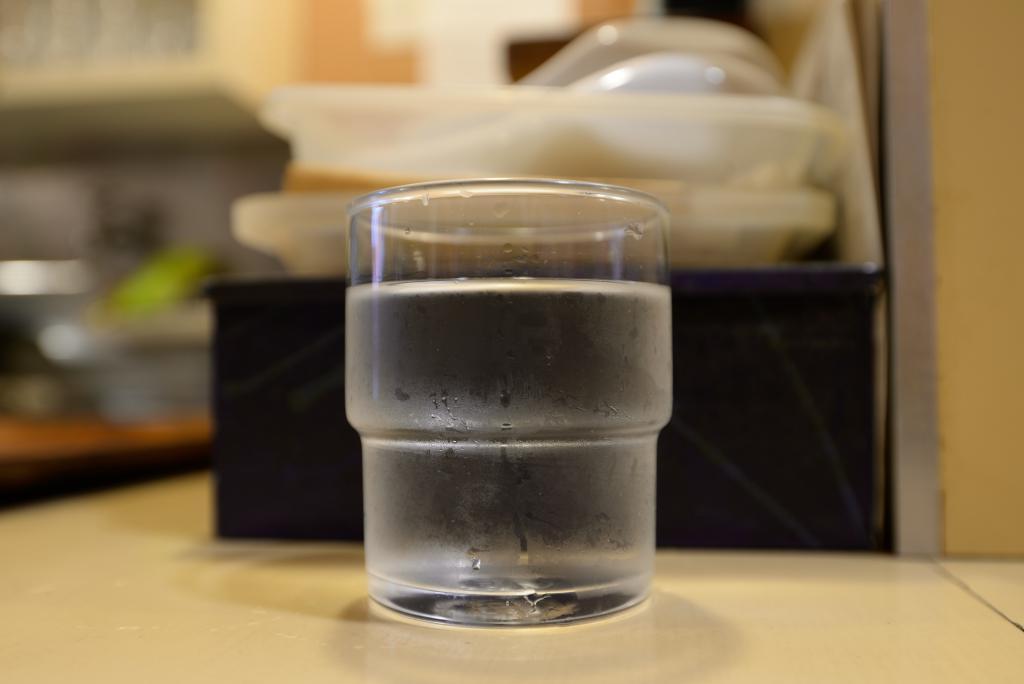How would you summarize this image in a sentence or two? In this picture we can see a glass of drink in the front, in the background there are some plastic bowls, there is a blurry background. 